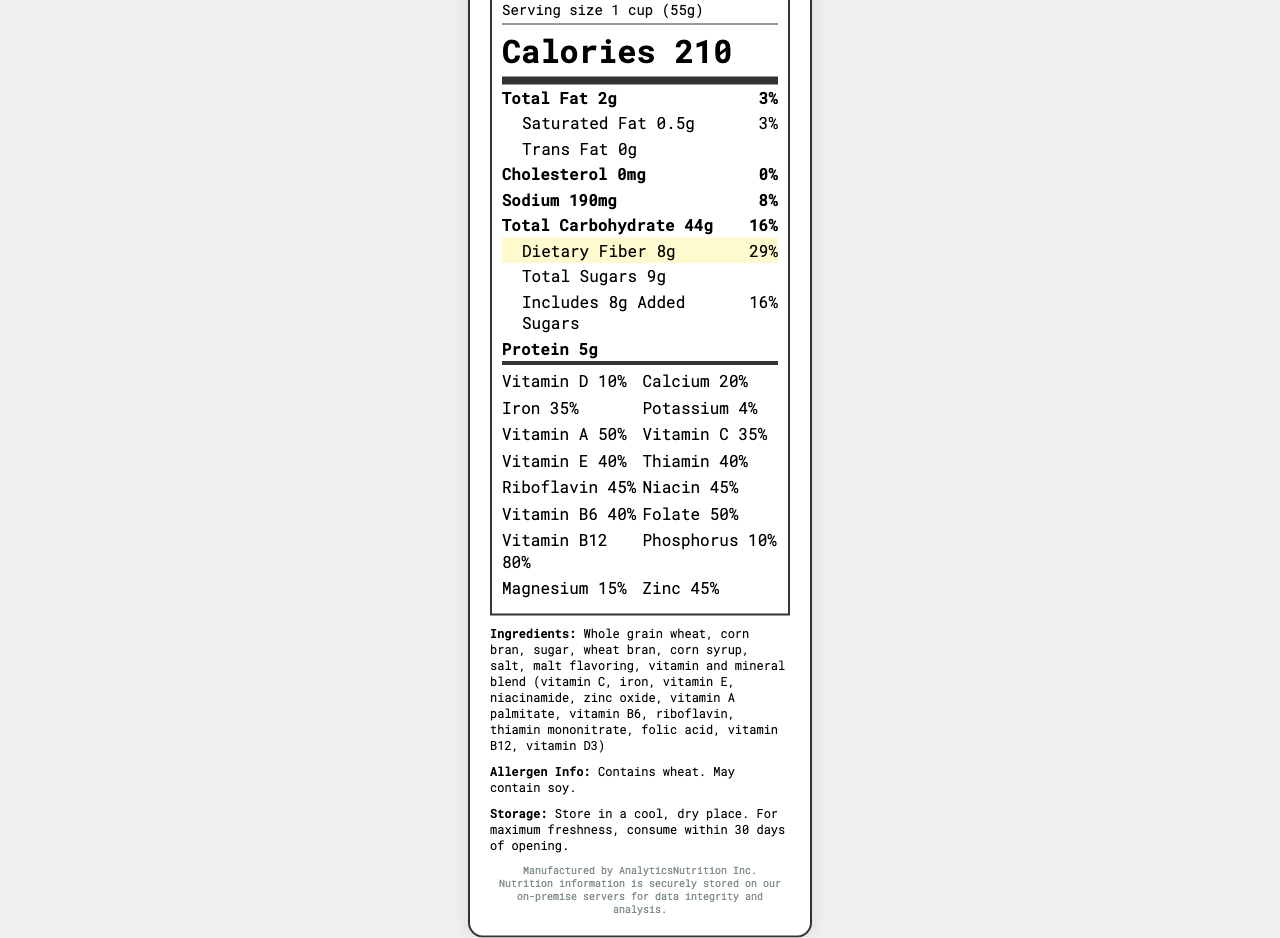what is the serving size for DataCrunch Fiber Flakes? The serving size is clearly listed as "1 cup (55g)" near the top of the label.
Answer: 1 cup (55g) how many servings are there in one container? The label specifies "About 12" servings per container.
Answer: About 12 how much dietary fiber is in one serving? The amount of dietary fiber is highlighted in the label as "8g" per serving.
Answer: 8g What is the daily value percentage of iron provided by one serving? The label indicates that one serving provides 35% of the daily value of iron.
Answer: 35% does this cereal contain any vitamin D? The label lists vitamin D with an amount of 2mcg and a daily value percentage of 10%.
Answer: Yes What ingredients are listed for DataCrunch Fiber Flakes? The ingredients are mentioned towards the bottom of the label.
Answer: Whole grain wheat, corn bran, sugar, wheat bran, corn syrup, salt, malt flavoring, vitamin and mineral blend (vitamin C, iron, vitamin E, niacinamide, zinc oxide, vitamin A palmitate, vitamin B6, riboflavin, thiamin mononitrate, folic acid, vitamin B12, vitamin D3) How many grams of total sugars are there per serving? The total sugars amount is listed as "9g" per serving.
Answer: 9g Which vitamin has the highest daily value percentage in the vitamins and minerals grid? A. Vitamin E B. Vitamin B12 C. Vitamin C D. Vitamin A The grid shows that vitamin B12 has an 80% daily value, which is the highest among the listed vitamins and minerals.
Answer: B. Vitamin B12 What percentage of daily value does magnesium contribute per serving? The magnesium daily value percentage listed in the vitamins and minerals grid is 15%.
Answer: 15% Is there any trans fat in DataCrunch Fiber Flakes? The label lists trans fat as "0g", indicating there is none.
Answer: No Who is the manufacturer of this cereal? A. NutriWellness Inc. B. AnalyticsNutrition Inc. C. HealthFactors Inc. The label states the cereal is manufactured by AnalyticsNutrition Inc.
Answer: B. AnalyticsNutrition Inc. Are there any allergens present in DataCrunch Fiber Flakes? The allergen information specifies that it contains wheat and may contain soy.
Answer: Yes, contains wheat. May contain soy. Summarize the main points of this nutrition label. The document provides a detailed breakdown of the nutritional content, ingredients, and allergen information for DataCrunch Fiber Flakes, a high-fiber fortified cereal, and highlights that it is produced by AnalyticsNutrition Inc.
Answer: DataCrunch Fiber Flakes is a vitamin-fortified, high-fiber breakfast cereal that offers nutritional benefits like 8g of dietary fiber (29% DV) and a variety of vitamins and minerals, including vitamin B12 (80% DV) and iron (35% DV). It contains 210 calories per serving, 2g of total fat, 9g of total sugars, and 5g of protein. Ingredients include whole grain wheat and corn bran. The product is manufactured by AnalyticsNutrition Inc. and contains wheat; it may also contain soy. What storage instructions are provided for DataCrunch Fiber Flakes? This information is found at the bottom of the label under the storage instructions.
Answer: Store in a cool, dry place. For maximum freshness, consume within 30 days of opening. How long should this cereal be consumed for maximum freshness after opening? The storage instructions indicate that for maximum freshness, the cereal should be consumed within 30 days of opening.
Answer: Within 30 days What is the specific vitamin and mineral blend mentioned in the ingredients? The specific vitamins and minerals are listed as part of the vitamin and mineral blend in the ingredients section.
Answer: Vitamin C, iron, vitamin E, niacinamide, zinc oxide, vitamin A palmitate, vitamin B6, riboflavin, thiamin mononitrate, folic acid, vitamin B12, vitamin D3 What company is responsible for data storage of the nutrition information? The footer of the document indicates that the nutrition information is securely stored on AnalyticsNutrition Inc.'s on-premise servers.
Answer: AnalyticsNutrition Inc. What is the total amount of carbohydrates per serving? How does it compare with the amount of dietary fiber? The total carbohydrate amount is 44g per serving, while the dietary fiber content is 8g, making up a significant portion of the carbohydrates.
Answer: Total carbohydrates: 44g; Dietary fiber: 8g How much riboflavin is in one serving? The amount of riboflavin per serving is listed as 0.6mg in the vitamins and minerals section.
Answer: 0.6mg What daily value percentage does potassium contribute? The label indicates that potassium contributes 4% to the daily value per serving.
Answer: 4% How would you rate the fiber content of this cereal? The cereal has 8g of dietary fiber per serving, corresponding to 29% of the daily value, indicating a high fiber content.
Answer: High Does this cereal contain any artificial flavors? The document does not specify whether the malt flavoring is artificial or natural, and no other artificial flavors are directly mentioned.
Answer: Cannot be determined 